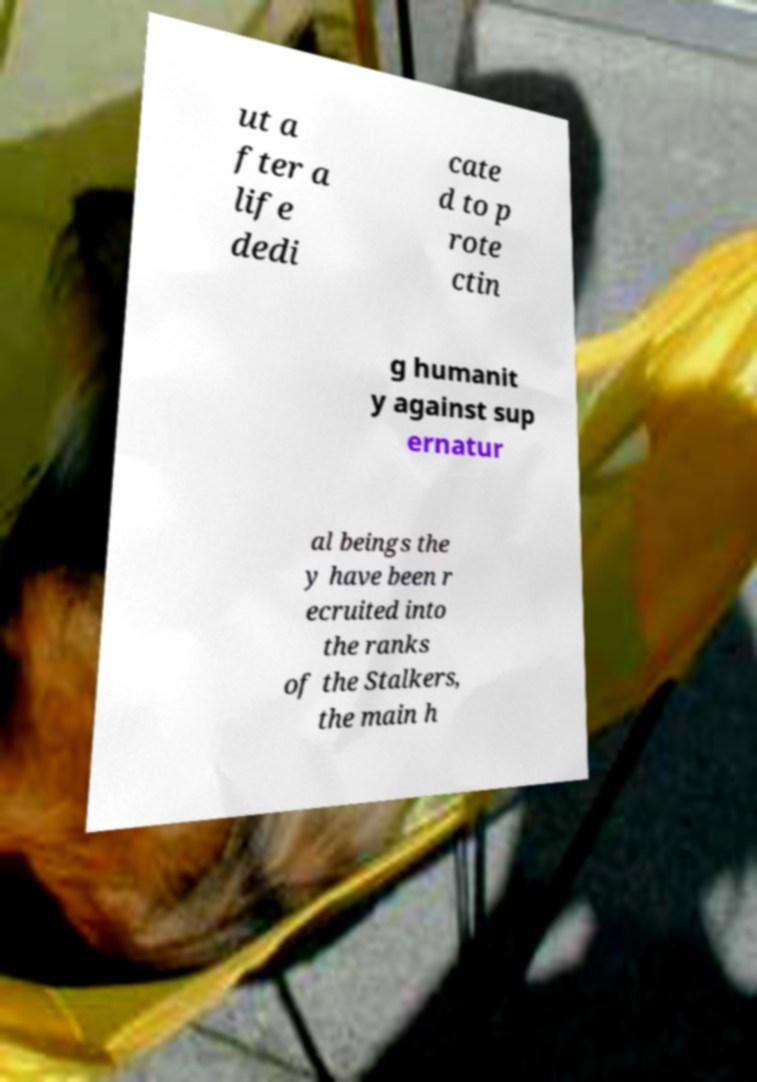For documentation purposes, I need the text within this image transcribed. Could you provide that? ut a fter a life dedi cate d to p rote ctin g humanit y against sup ernatur al beings the y have been r ecruited into the ranks of the Stalkers, the main h 